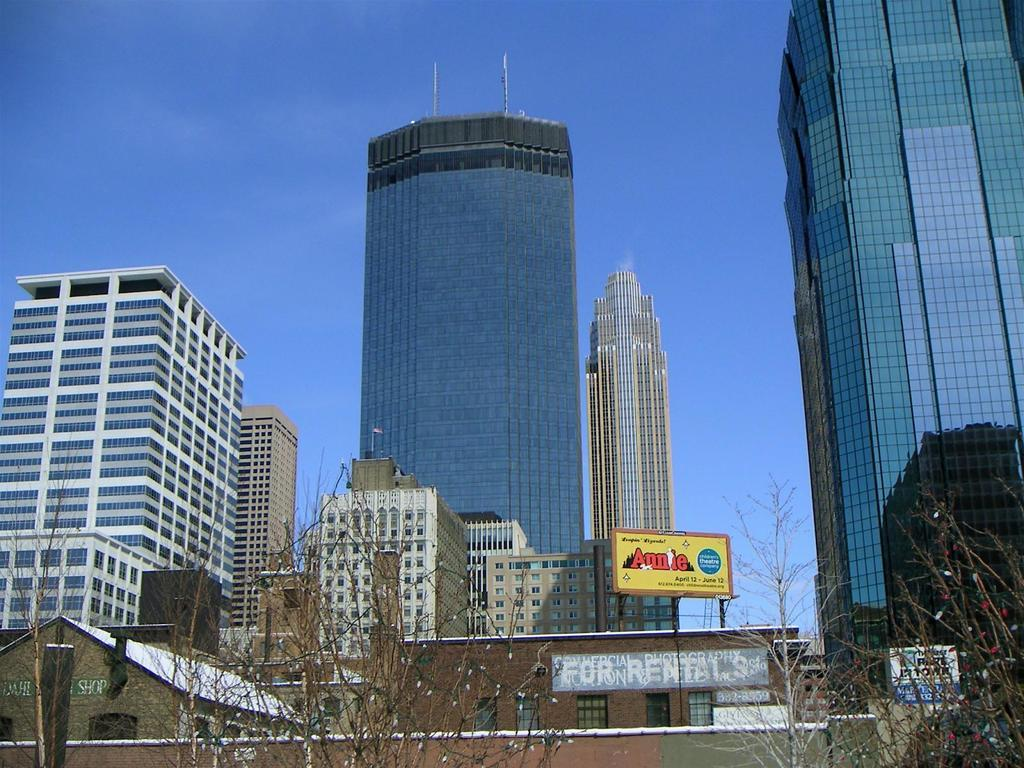What type of location is shown in the image? The image depicts a city. What structures can be seen in the city? There are buildings in the image. Are there any natural elements present in the city? Yes, there are trees in the image. What type of advertisements can be seen in the city? There are hoardings in the image. What is visible at the top of the image? The sky is visible at the top of the image. How does the elbow of the city contribute to its digestion process? There is no mention of an elbow or a digestion process in the image, as it depicts a city with buildings, trees, hoardings, and a visible sky. 